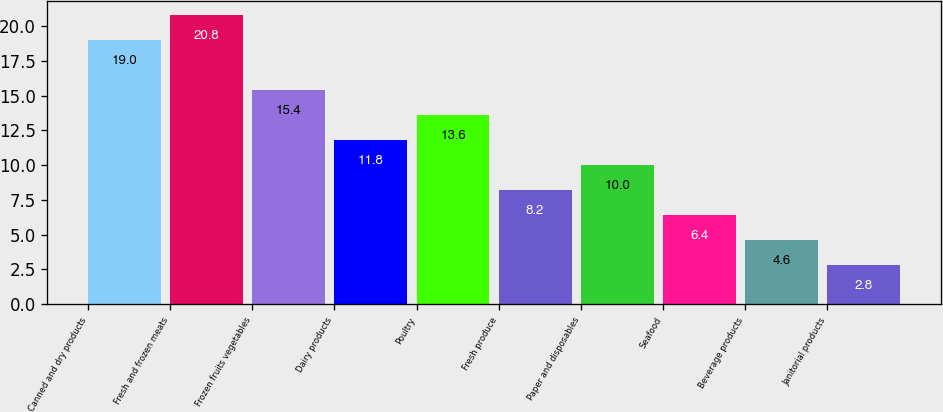Convert chart. <chart><loc_0><loc_0><loc_500><loc_500><bar_chart><fcel>Canned and dry products<fcel>Fresh and frozen meats<fcel>Frozen fruits vegetables<fcel>Dairy products<fcel>Poultry<fcel>Fresh produce<fcel>Paper and disposables<fcel>Seafood<fcel>Beverage products<fcel>Janitorial products<nl><fcel>19<fcel>20.8<fcel>15.4<fcel>11.8<fcel>13.6<fcel>8.2<fcel>10<fcel>6.4<fcel>4.6<fcel>2.8<nl></chart> 